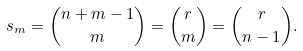Convert formula to latex. <formula><loc_0><loc_0><loc_500><loc_500>s _ { m } = \binom { n + m - 1 } { m } = \binom { r } { m } = \binom { r } { n - 1 } .</formula> 